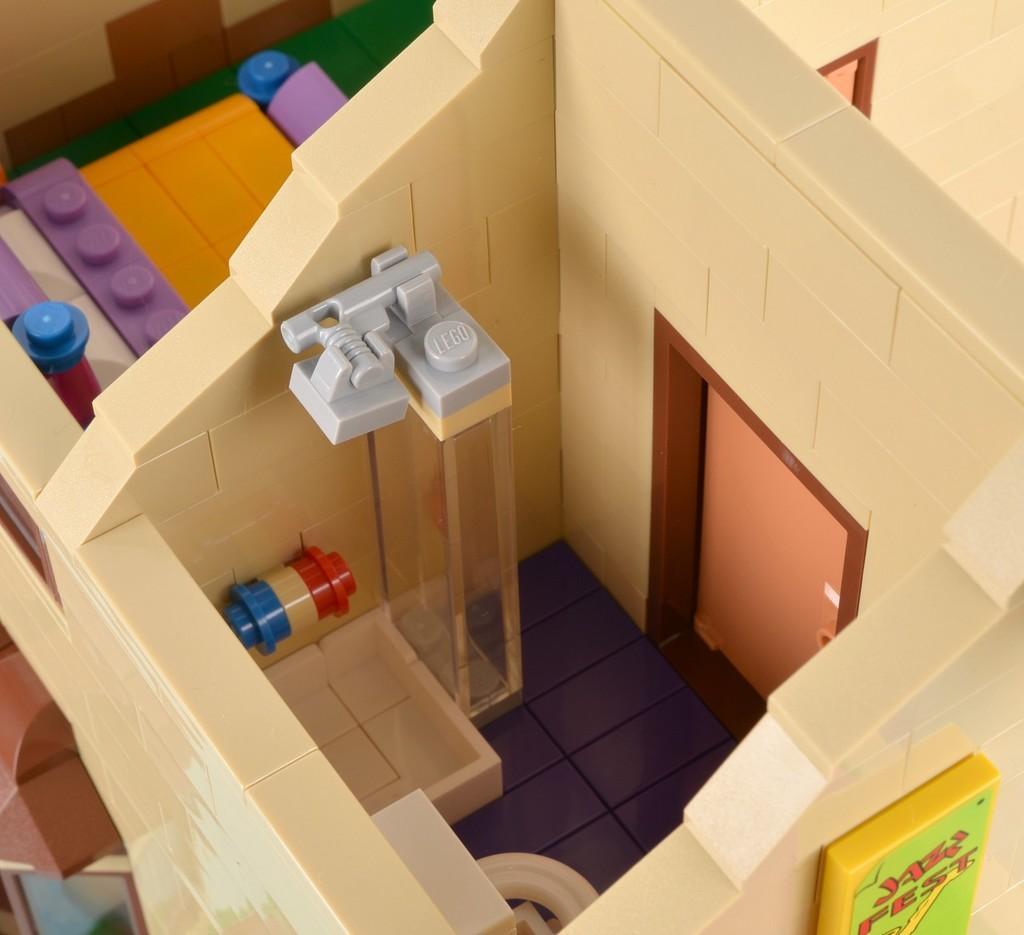Could you give a brief overview of what you see in this image? In this image in the center there is toy house. 